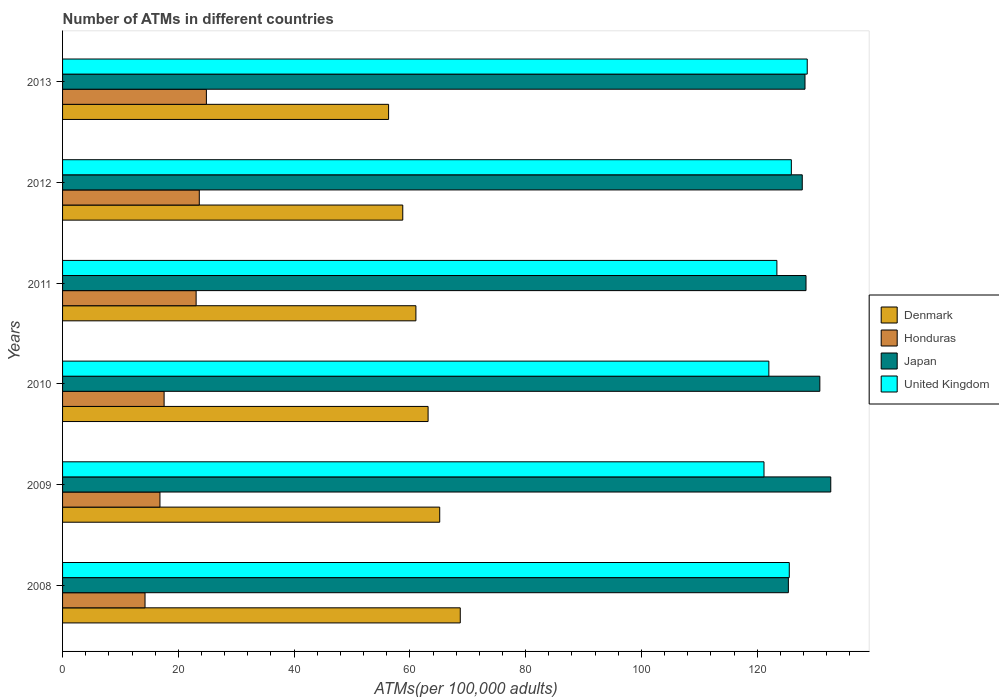How many groups of bars are there?
Offer a terse response. 6. Are the number of bars per tick equal to the number of legend labels?
Offer a terse response. Yes. Are the number of bars on each tick of the Y-axis equal?
Your answer should be compact. Yes. How many bars are there on the 2nd tick from the bottom?
Your answer should be very brief. 4. What is the number of ATMs in Honduras in 2009?
Give a very brief answer. 16.82. Across all years, what is the maximum number of ATMs in Honduras?
Your answer should be very brief. 24.85. Across all years, what is the minimum number of ATMs in Honduras?
Your response must be concise. 14.25. What is the total number of ATMs in United Kingdom in the graph?
Provide a succinct answer. 746.69. What is the difference between the number of ATMs in United Kingdom in 2009 and that in 2010?
Your answer should be compact. -0.84. What is the difference between the number of ATMs in Japan in 2010 and the number of ATMs in United Kingdom in 2011?
Offer a very short reply. 7.42. What is the average number of ATMs in Honduras per year?
Offer a very short reply. 20.03. In the year 2010, what is the difference between the number of ATMs in United Kingdom and number of ATMs in Denmark?
Ensure brevity in your answer.  58.87. In how many years, is the number of ATMs in Japan greater than 20 ?
Your answer should be compact. 6. What is the ratio of the number of ATMs in Honduras in 2012 to that in 2013?
Your answer should be compact. 0.95. What is the difference between the highest and the second highest number of ATMs in Japan?
Ensure brevity in your answer.  1.89. What is the difference between the highest and the lowest number of ATMs in Denmark?
Make the answer very short. 12.38. Is it the case that in every year, the sum of the number of ATMs in Honduras and number of ATMs in Japan is greater than the sum of number of ATMs in United Kingdom and number of ATMs in Denmark?
Keep it short and to the point. Yes. What does the 1st bar from the top in 2008 represents?
Offer a very short reply. United Kingdom. Is it the case that in every year, the sum of the number of ATMs in Japan and number of ATMs in United Kingdom is greater than the number of ATMs in Denmark?
Keep it short and to the point. Yes. Are all the bars in the graph horizontal?
Offer a very short reply. Yes. Are the values on the major ticks of X-axis written in scientific E-notation?
Your answer should be compact. No. Does the graph contain any zero values?
Give a very brief answer. No. Where does the legend appear in the graph?
Provide a short and direct response. Center right. How are the legend labels stacked?
Your answer should be compact. Vertical. What is the title of the graph?
Offer a very short reply. Number of ATMs in different countries. Does "Mongolia" appear as one of the legend labels in the graph?
Give a very brief answer. No. What is the label or title of the X-axis?
Provide a succinct answer. ATMs(per 100,0 adults). What is the label or title of the Y-axis?
Make the answer very short. Years. What is the ATMs(per 100,000 adults) of Denmark in 2008?
Ensure brevity in your answer.  68.71. What is the ATMs(per 100,000 adults) in Honduras in 2008?
Provide a succinct answer. 14.25. What is the ATMs(per 100,000 adults) of Japan in 2008?
Your answer should be very brief. 125.39. What is the ATMs(per 100,000 adults) in United Kingdom in 2008?
Keep it short and to the point. 125.55. What is the ATMs(per 100,000 adults) of Denmark in 2009?
Offer a terse response. 65.16. What is the ATMs(per 100,000 adults) of Honduras in 2009?
Make the answer very short. 16.82. What is the ATMs(per 100,000 adults) in Japan in 2009?
Provide a short and direct response. 132.71. What is the ATMs(per 100,000 adults) in United Kingdom in 2009?
Your answer should be compact. 121.18. What is the ATMs(per 100,000 adults) of Denmark in 2010?
Your answer should be very brief. 63.15. What is the ATMs(per 100,000 adults) of Honduras in 2010?
Your answer should be very brief. 17.54. What is the ATMs(per 100,000 adults) of Japan in 2010?
Keep it short and to the point. 130.82. What is the ATMs(per 100,000 adults) in United Kingdom in 2010?
Make the answer very short. 122.02. What is the ATMs(per 100,000 adults) in Denmark in 2011?
Keep it short and to the point. 61.04. What is the ATMs(per 100,000 adults) in Honduras in 2011?
Offer a very short reply. 23.07. What is the ATMs(per 100,000 adults) in Japan in 2011?
Make the answer very short. 128.44. What is the ATMs(per 100,000 adults) in United Kingdom in 2011?
Give a very brief answer. 123.4. What is the ATMs(per 100,000 adults) of Denmark in 2012?
Provide a short and direct response. 58.77. What is the ATMs(per 100,000 adults) of Honduras in 2012?
Give a very brief answer. 23.62. What is the ATMs(per 100,000 adults) in Japan in 2012?
Keep it short and to the point. 127.79. What is the ATMs(per 100,000 adults) of United Kingdom in 2012?
Offer a very short reply. 125.9. What is the ATMs(per 100,000 adults) of Denmark in 2013?
Your answer should be compact. 56.32. What is the ATMs(per 100,000 adults) in Honduras in 2013?
Make the answer very short. 24.85. What is the ATMs(per 100,000 adults) of Japan in 2013?
Make the answer very short. 128.26. What is the ATMs(per 100,000 adults) of United Kingdom in 2013?
Your answer should be compact. 128.65. Across all years, what is the maximum ATMs(per 100,000 adults) of Denmark?
Offer a terse response. 68.71. Across all years, what is the maximum ATMs(per 100,000 adults) in Honduras?
Your answer should be compact. 24.85. Across all years, what is the maximum ATMs(per 100,000 adults) of Japan?
Your answer should be compact. 132.71. Across all years, what is the maximum ATMs(per 100,000 adults) in United Kingdom?
Your answer should be compact. 128.65. Across all years, what is the minimum ATMs(per 100,000 adults) of Denmark?
Give a very brief answer. 56.32. Across all years, what is the minimum ATMs(per 100,000 adults) in Honduras?
Give a very brief answer. 14.25. Across all years, what is the minimum ATMs(per 100,000 adults) in Japan?
Keep it short and to the point. 125.39. Across all years, what is the minimum ATMs(per 100,000 adults) of United Kingdom?
Ensure brevity in your answer.  121.18. What is the total ATMs(per 100,000 adults) in Denmark in the graph?
Offer a very short reply. 373.15. What is the total ATMs(per 100,000 adults) in Honduras in the graph?
Make the answer very short. 120.15. What is the total ATMs(per 100,000 adults) of Japan in the graph?
Your answer should be very brief. 773.41. What is the total ATMs(per 100,000 adults) of United Kingdom in the graph?
Provide a short and direct response. 746.69. What is the difference between the ATMs(per 100,000 adults) of Denmark in 2008 and that in 2009?
Your answer should be compact. 3.55. What is the difference between the ATMs(per 100,000 adults) of Honduras in 2008 and that in 2009?
Provide a succinct answer. -2.58. What is the difference between the ATMs(per 100,000 adults) in Japan in 2008 and that in 2009?
Offer a terse response. -7.32. What is the difference between the ATMs(per 100,000 adults) in United Kingdom in 2008 and that in 2009?
Offer a very short reply. 4.37. What is the difference between the ATMs(per 100,000 adults) of Denmark in 2008 and that in 2010?
Your answer should be compact. 5.56. What is the difference between the ATMs(per 100,000 adults) of Honduras in 2008 and that in 2010?
Ensure brevity in your answer.  -3.29. What is the difference between the ATMs(per 100,000 adults) of Japan in 2008 and that in 2010?
Provide a short and direct response. -5.44. What is the difference between the ATMs(per 100,000 adults) in United Kingdom in 2008 and that in 2010?
Make the answer very short. 3.53. What is the difference between the ATMs(per 100,000 adults) in Denmark in 2008 and that in 2011?
Your answer should be compact. 7.66. What is the difference between the ATMs(per 100,000 adults) of Honduras in 2008 and that in 2011?
Offer a very short reply. -8.83. What is the difference between the ATMs(per 100,000 adults) in Japan in 2008 and that in 2011?
Your answer should be compact. -3.05. What is the difference between the ATMs(per 100,000 adults) in United Kingdom in 2008 and that in 2011?
Keep it short and to the point. 2.14. What is the difference between the ATMs(per 100,000 adults) in Denmark in 2008 and that in 2012?
Provide a succinct answer. 9.93. What is the difference between the ATMs(per 100,000 adults) in Honduras in 2008 and that in 2012?
Ensure brevity in your answer.  -9.37. What is the difference between the ATMs(per 100,000 adults) of Japan in 2008 and that in 2012?
Give a very brief answer. -2.4. What is the difference between the ATMs(per 100,000 adults) of United Kingdom in 2008 and that in 2012?
Offer a terse response. -0.36. What is the difference between the ATMs(per 100,000 adults) in Denmark in 2008 and that in 2013?
Keep it short and to the point. 12.38. What is the difference between the ATMs(per 100,000 adults) in Honduras in 2008 and that in 2013?
Ensure brevity in your answer.  -10.6. What is the difference between the ATMs(per 100,000 adults) of Japan in 2008 and that in 2013?
Offer a terse response. -2.87. What is the difference between the ATMs(per 100,000 adults) in United Kingdom in 2008 and that in 2013?
Keep it short and to the point. -3.1. What is the difference between the ATMs(per 100,000 adults) of Denmark in 2009 and that in 2010?
Your answer should be compact. 2.01. What is the difference between the ATMs(per 100,000 adults) of Honduras in 2009 and that in 2010?
Offer a terse response. -0.72. What is the difference between the ATMs(per 100,000 adults) of Japan in 2009 and that in 2010?
Provide a succinct answer. 1.89. What is the difference between the ATMs(per 100,000 adults) of United Kingdom in 2009 and that in 2010?
Keep it short and to the point. -0.84. What is the difference between the ATMs(per 100,000 adults) in Denmark in 2009 and that in 2011?
Provide a short and direct response. 4.11. What is the difference between the ATMs(per 100,000 adults) in Honduras in 2009 and that in 2011?
Offer a very short reply. -6.25. What is the difference between the ATMs(per 100,000 adults) in Japan in 2009 and that in 2011?
Ensure brevity in your answer.  4.28. What is the difference between the ATMs(per 100,000 adults) in United Kingdom in 2009 and that in 2011?
Your response must be concise. -2.23. What is the difference between the ATMs(per 100,000 adults) of Denmark in 2009 and that in 2012?
Give a very brief answer. 6.38. What is the difference between the ATMs(per 100,000 adults) in Honduras in 2009 and that in 2012?
Ensure brevity in your answer.  -6.8. What is the difference between the ATMs(per 100,000 adults) in Japan in 2009 and that in 2012?
Provide a short and direct response. 4.92. What is the difference between the ATMs(per 100,000 adults) of United Kingdom in 2009 and that in 2012?
Your response must be concise. -4.72. What is the difference between the ATMs(per 100,000 adults) in Denmark in 2009 and that in 2013?
Ensure brevity in your answer.  8.83. What is the difference between the ATMs(per 100,000 adults) in Honduras in 2009 and that in 2013?
Your response must be concise. -8.02. What is the difference between the ATMs(per 100,000 adults) in Japan in 2009 and that in 2013?
Keep it short and to the point. 4.45. What is the difference between the ATMs(per 100,000 adults) of United Kingdom in 2009 and that in 2013?
Your response must be concise. -7.47. What is the difference between the ATMs(per 100,000 adults) of Denmark in 2010 and that in 2011?
Your answer should be very brief. 2.11. What is the difference between the ATMs(per 100,000 adults) in Honduras in 2010 and that in 2011?
Your answer should be compact. -5.53. What is the difference between the ATMs(per 100,000 adults) in Japan in 2010 and that in 2011?
Your response must be concise. 2.39. What is the difference between the ATMs(per 100,000 adults) of United Kingdom in 2010 and that in 2011?
Your response must be concise. -1.39. What is the difference between the ATMs(per 100,000 adults) in Denmark in 2010 and that in 2012?
Provide a short and direct response. 4.38. What is the difference between the ATMs(per 100,000 adults) of Honduras in 2010 and that in 2012?
Keep it short and to the point. -6.08. What is the difference between the ATMs(per 100,000 adults) in Japan in 2010 and that in 2012?
Keep it short and to the point. 3.04. What is the difference between the ATMs(per 100,000 adults) of United Kingdom in 2010 and that in 2012?
Provide a short and direct response. -3.89. What is the difference between the ATMs(per 100,000 adults) of Denmark in 2010 and that in 2013?
Your answer should be very brief. 6.83. What is the difference between the ATMs(per 100,000 adults) of Honduras in 2010 and that in 2013?
Provide a succinct answer. -7.3. What is the difference between the ATMs(per 100,000 adults) of Japan in 2010 and that in 2013?
Ensure brevity in your answer.  2.56. What is the difference between the ATMs(per 100,000 adults) in United Kingdom in 2010 and that in 2013?
Keep it short and to the point. -6.63. What is the difference between the ATMs(per 100,000 adults) in Denmark in 2011 and that in 2012?
Offer a very short reply. 2.27. What is the difference between the ATMs(per 100,000 adults) of Honduras in 2011 and that in 2012?
Give a very brief answer. -0.55. What is the difference between the ATMs(per 100,000 adults) in Japan in 2011 and that in 2012?
Provide a short and direct response. 0.65. What is the difference between the ATMs(per 100,000 adults) in United Kingdom in 2011 and that in 2012?
Your answer should be very brief. -2.5. What is the difference between the ATMs(per 100,000 adults) of Denmark in 2011 and that in 2013?
Provide a short and direct response. 4.72. What is the difference between the ATMs(per 100,000 adults) of Honduras in 2011 and that in 2013?
Your response must be concise. -1.77. What is the difference between the ATMs(per 100,000 adults) in Japan in 2011 and that in 2013?
Offer a terse response. 0.17. What is the difference between the ATMs(per 100,000 adults) of United Kingdom in 2011 and that in 2013?
Provide a succinct answer. -5.24. What is the difference between the ATMs(per 100,000 adults) in Denmark in 2012 and that in 2013?
Give a very brief answer. 2.45. What is the difference between the ATMs(per 100,000 adults) in Honduras in 2012 and that in 2013?
Make the answer very short. -1.22. What is the difference between the ATMs(per 100,000 adults) of Japan in 2012 and that in 2013?
Your response must be concise. -0.47. What is the difference between the ATMs(per 100,000 adults) in United Kingdom in 2012 and that in 2013?
Ensure brevity in your answer.  -2.74. What is the difference between the ATMs(per 100,000 adults) of Denmark in 2008 and the ATMs(per 100,000 adults) of Honduras in 2009?
Offer a terse response. 51.88. What is the difference between the ATMs(per 100,000 adults) of Denmark in 2008 and the ATMs(per 100,000 adults) of Japan in 2009?
Offer a terse response. -64.01. What is the difference between the ATMs(per 100,000 adults) in Denmark in 2008 and the ATMs(per 100,000 adults) in United Kingdom in 2009?
Offer a terse response. -52.47. What is the difference between the ATMs(per 100,000 adults) in Honduras in 2008 and the ATMs(per 100,000 adults) in Japan in 2009?
Provide a succinct answer. -118.47. What is the difference between the ATMs(per 100,000 adults) in Honduras in 2008 and the ATMs(per 100,000 adults) in United Kingdom in 2009?
Offer a very short reply. -106.93. What is the difference between the ATMs(per 100,000 adults) in Japan in 2008 and the ATMs(per 100,000 adults) in United Kingdom in 2009?
Keep it short and to the point. 4.21. What is the difference between the ATMs(per 100,000 adults) in Denmark in 2008 and the ATMs(per 100,000 adults) in Honduras in 2010?
Your answer should be very brief. 51.16. What is the difference between the ATMs(per 100,000 adults) in Denmark in 2008 and the ATMs(per 100,000 adults) in Japan in 2010?
Offer a terse response. -62.12. What is the difference between the ATMs(per 100,000 adults) in Denmark in 2008 and the ATMs(per 100,000 adults) in United Kingdom in 2010?
Offer a terse response. -53.31. What is the difference between the ATMs(per 100,000 adults) in Honduras in 2008 and the ATMs(per 100,000 adults) in Japan in 2010?
Make the answer very short. -116.58. What is the difference between the ATMs(per 100,000 adults) in Honduras in 2008 and the ATMs(per 100,000 adults) in United Kingdom in 2010?
Your response must be concise. -107.77. What is the difference between the ATMs(per 100,000 adults) of Japan in 2008 and the ATMs(per 100,000 adults) of United Kingdom in 2010?
Provide a succinct answer. 3.37. What is the difference between the ATMs(per 100,000 adults) of Denmark in 2008 and the ATMs(per 100,000 adults) of Honduras in 2011?
Keep it short and to the point. 45.63. What is the difference between the ATMs(per 100,000 adults) in Denmark in 2008 and the ATMs(per 100,000 adults) in Japan in 2011?
Provide a short and direct response. -59.73. What is the difference between the ATMs(per 100,000 adults) in Denmark in 2008 and the ATMs(per 100,000 adults) in United Kingdom in 2011?
Keep it short and to the point. -54.7. What is the difference between the ATMs(per 100,000 adults) in Honduras in 2008 and the ATMs(per 100,000 adults) in Japan in 2011?
Offer a very short reply. -114.19. What is the difference between the ATMs(per 100,000 adults) of Honduras in 2008 and the ATMs(per 100,000 adults) of United Kingdom in 2011?
Offer a terse response. -109.16. What is the difference between the ATMs(per 100,000 adults) in Japan in 2008 and the ATMs(per 100,000 adults) in United Kingdom in 2011?
Your answer should be very brief. 1.98. What is the difference between the ATMs(per 100,000 adults) in Denmark in 2008 and the ATMs(per 100,000 adults) in Honduras in 2012?
Your response must be concise. 45.08. What is the difference between the ATMs(per 100,000 adults) of Denmark in 2008 and the ATMs(per 100,000 adults) of Japan in 2012?
Offer a very short reply. -59.08. What is the difference between the ATMs(per 100,000 adults) of Denmark in 2008 and the ATMs(per 100,000 adults) of United Kingdom in 2012?
Provide a short and direct response. -57.2. What is the difference between the ATMs(per 100,000 adults) of Honduras in 2008 and the ATMs(per 100,000 adults) of Japan in 2012?
Ensure brevity in your answer.  -113.54. What is the difference between the ATMs(per 100,000 adults) in Honduras in 2008 and the ATMs(per 100,000 adults) in United Kingdom in 2012?
Offer a terse response. -111.65. What is the difference between the ATMs(per 100,000 adults) in Japan in 2008 and the ATMs(per 100,000 adults) in United Kingdom in 2012?
Keep it short and to the point. -0.51. What is the difference between the ATMs(per 100,000 adults) in Denmark in 2008 and the ATMs(per 100,000 adults) in Honduras in 2013?
Your response must be concise. 43.86. What is the difference between the ATMs(per 100,000 adults) of Denmark in 2008 and the ATMs(per 100,000 adults) of Japan in 2013?
Provide a succinct answer. -59.56. What is the difference between the ATMs(per 100,000 adults) of Denmark in 2008 and the ATMs(per 100,000 adults) of United Kingdom in 2013?
Your answer should be compact. -59.94. What is the difference between the ATMs(per 100,000 adults) of Honduras in 2008 and the ATMs(per 100,000 adults) of Japan in 2013?
Make the answer very short. -114.01. What is the difference between the ATMs(per 100,000 adults) of Honduras in 2008 and the ATMs(per 100,000 adults) of United Kingdom in 2013?
Offer a terse response. -114.4. What is the difference between the ATMs(per 100,000 adults) in Japan in 2008 and the ATMs(per 100,000 adults) in United Kingdom in 2013?
Provide a succinct answer. -3.26. What is the difference between the ATMs(per 100,000 adults) in Denmark in 2009 and the ATMs(per 100,000 adults) in Honduras in 2010?
Offer a very short reply. 47.61. What is the difference between the ATMs(per 100,000 adults) of Denmark in 2009 and the ATMs(per 100,000 adults) of Japan in 2010?
Your response must be concise. -65.67. What is the difference between the ATMs(per 100,000 adults) of Denmark in 2009 and the ATMs(per 100,000 adults) of United Kingdom in 2010?
Provide a short and direct response. -56.86. What is the difference between the ATMs(per 100,000 adults) in Honduras in 2009 and the ATMs(per 100,000 adults) in Japan in 2010?
Ensure brevity in your answer.  -114. What is the difference between the ATMs(per 100,000 adults) in Honduras in 2009 and the ATMs(per 100,000 adults) in United Kingdom in 2010?
Provide a succinct answer. -105.19. What is the difference between the ATMs(per 100,000 adults) of Japan in 2009 and the ATMs(per 100,000 adults) of United Kingdom in 2010?
Your answer should be very brief. 10.7. What is the difference between the ATMs(per 100,000 adults) in Denmark in 2009 and the ATMs(per 100,000 adults) in Honduras in 2011?
Give a very brief answer. 42.08. What is the difference between the ATMs(per 100,000 adults) in Denmark in 2009 and the ATMs(per 100,000 adults) in Japan in 2011?
Your answer should be very brief. -63.28. What is the difference between the ATMs(per 100,000 adults) in Denmark in 2009 and the ATMs(per 100,000 adults) in United Kingdom in 2011?
Offer a terse response. -58.25. What is the difference between the ATMs(per 100,000 adults) of Honduras in 2009 and the ATMs(per 100,000 adults) of Japan in 2011?
Offer a terse response. -111.61. What is the difference between the ATMs(per 100,000 adults) in Honduras in 2009 and the ATMs(per 100,000 adults) in United Kingdom in 2011?
Ensure brevity in your answer.  -106.58. What is the difference between the ATMs(per 100,000 adults) of Japan in 2009 and the ATMs(per 100,000 adults) of United Kingdom in 2011?
Make the answer very short. 9.31. What is the difference between the ATMs(per 100,000 adults) in Denmark in 2009 and the ATMs(per 100,000 adults) in Honduras in 2012?
Your response must be concise. 41.54. What is the difference between the ATMs(per 100,000 adults) in Denmark in 2009 and the ATMs(per 100,000 adults) in Japan in 2012?
Make the answer very short. -62.63. What is the difference between the ATMs(per 100,000 adults) in Denmark in 2009 and the ATMs(per 100,000 adults) in United Kingdom in 2012?
Give a very brief answer. -60.75. What is the difference between the ATMs(per 100,000 adults) in Honduras in 2009 and the ATMs(per 100,000 adults) in Japan in 2012?
Offer a very short reply. -110.96. What is the difference between the ATMs(per 100,000 adults) of Honduras in 2009 and the ATMs(per 100,000 adults) of United Kingdom in 2012?
Provide a short and direct response. -109.08. What is the difference between the ATMs(per 100,000 adults) in Japan in 2009 and the ATMs(per 100,000 adults) in United Kingdom in 2012?
Your response must be concise. 6.81. What is the difference between the ATMs(per 100,000 adults) in Denmark in 2009 and the ATMs(per 100,000 adults) in Honduras in 2013?
Keep it short and to the point. 40.31. What is the difference between the ATMs(per 100,000 adults) of Denmark in 2009 and the ATMs(per 100,000 adults) of Japan in 2013?
Ensure brevity in your answer.  -63.1. What is the difference between the ATMs(per 100,000 adults) of Denmark in 2009 and the ATMs(per 100,000 adults) of United Kingdom in 2013?
Your answer should be very brief. -63.49. What is the difference between the ATMs(per 100,000 adults) of Honduras in 2009 and the ATMs(per 100,000 adults) of Japan in 2013?
Your answer should be very brief. -111.44. What is the difference between the ATMs(per 100,000 adults) in Honduras in 2009 and the ATMs(per 100,000 adults) in United Kingdom in 2013?
Your response must be concise. -111.82. What is the difference between the ATMs(per 100,000 adults) in Japan in 2009 and the ATMs(per 100,000 adults) in United Kingdom in 2013?
Your response must be concise. 4.07. What is the difference between the ATMs(per 100,000 adults) in Denmark in 2010 and the ATMs(per 100,000 adults) in Honduras in 2011?
Offer a very short reply. 40.08. What is the difference between the ATMs(per 100,000 adults) in Denmark in 2010 and the ATMs(per 100,000 adults) in Japan in 2011?
Offer a very short reply. -65.29. What is the difference between the ATMs(per 100,000 adults) in Denmark in 2010 and the ATMs(per 100,000 adults) in United Kingdom in 2011?
Offer a terse response. -60.26. What is the difference between the ATMs(per 100,000 adults) of Honduras in 2010 and the ATMs(per 100,000 adults) of Japan in 2011?
Make the answer very short. -110.89. What is the difference between the ATMs(per 100,000 adults) in Honduras in 2010 and the ATMs(per 100,000 adults) in United Kingdom in 2011?
Keep it short and to the point. -105.86. What is the difference between the ATMs(per 100,000 adults) in Japan in 2010 and the ATMs(per 100,000 adults) in United Kingdom in 2011?
Ensure brevity in your answer.  7.42. What is the difference between the ATMs(per 100,000 adults) of Denmark in 2010 and the ATMs(per 100,000 adults) of Honduras in 2012?
Offer a terse response. 39.53. What is the difference between the ATMs(per 100,000 adults) in Denmark in 2010 and the ATMs(per 100,000 adults) in Japan in 2012?
Give a very brief answer. -64.64. What is the difference between the ATMs(per 100,000 adults) of Denmark in 2010 and the ATMs(per 100,000 adults) of United Kingdom in 2012?
Your answer should be very brief. -62.75. What is the difference between the ATMs(per 100,000 adults) in Honduras in 2010 and the ATMs(per 100,000 adults) in Japan in 2012?
Keep it short and to the point. -110.25. What is the difference between the ATMs(per 100,000 adults) of Honduras in 2010 and the ATMs(per 100,000 adults) of United Kingdom in 2012?
Your response must be concise. -108.36. What is the difference between the ATMs(per 100,000 adults) in Japan in 2010 and the ATMs(per 100,000 adults) in United Kingdom in 2012?
Your answer should be compact. 4.92. What is the difference between the ATMs(per 100,000 adults) in Denmark in 2010 and the ATMs(per 100,000 adults) in Honduras in 2013?
Provide a short and direct response. 38.3. What is the difference between the ATMs(per 100,000 adults) in Denmark in 2010 and the ATMs(per 100,000 adults) in Japan in 2013?
Provide a short and direct response. -65.11. What is the difference between the ATMs(per 100,000 adults) of Denmark in 2010 and the ATMs(per 100,000 adults) of United Kingdom in 2013?
Offer a terse response. -65.5. What is the difference between the ATMs(per 100,000 adults) in Honduras in 2010 and the ATMs(per 100,000 adults) in Japan in 2013?
Offer a very short reply. -110.72. What is the difference between the ATMs(per 100,000 adults) of Honduras in 2010 and the ATMs(per 100,000 adults) of United Kingdom in 2013?
Offer a very short reply. -111.1. What is the difference between the ATMs(per 100,000 adults) in Japan in 2010 and the ATMs(per 100,000 adults) in United Kingdom in 2013?
Offer a terse response. 2.18. What is the difference between the ATMs(per 100,000 adults) in Denmark in 2011 and the ATMs(per 100,000 adults) in Honduras in 2012?
Offer a terse response. 37.42. What is the difference between the ATMs(per 100,000 adults) of Denmark in 2011 and the ATMs(per 100,000 adults) of Japan in 2012?
Your answer should be compact. -66.75. What is the difference between the ATMs(per 100,000 adults) of Denmark in 2011 and the ATMs(per 100,000 adults) of United Kingdom in 2012?
Offer a terse response. -64.86. What is the difference between the ATMs(per 100,000 adults) in Honduras in 2011 and the ATMs(per 100,000 adults) in Japan in 2012?
Make the answer very short. -104.72. What is the difference between the ATMs(per 100,000 adults) of Honduras in 2011 and the ATMs(per 100,000 adults) of United Kingdom in 2012?
Offer a terse response. -102.83. What is the difference between the ATMs(per 100,000 adults) in Japan in 2011 and the ATMs(per 100,000 adults) in United Kingdom in 2012?
Offer a very short reply. 2.53. What is the difference between the ATMs(per 100,000 adults) in Denmark in 2011 and the ATMs(per 100,000 adults) in Honduras in 2013?
Provide a short and direct response. 36.2. What is the difference between the ATMs(per 100,000 adults) in Denmark in 2011 and the ATMs(per 100,000 adults) in Japan in 2013?
Ensure brevity in your answer.  -67.22. What is the difference between the ATMs(per 100,000 adults) in Denmark in 2011 and the ATMs(per 100,000 adults) in United Kingdom in 2013?
Keep it short and to the point. -67.6. What is the difference between the ATMs(per 100,000 adults) in Honduras in 2011 and the ATMs(per 100,000 adults) in Japan in 2013?
Your response must be concise. -105.19. What is the difference between the ATMs(per 100,000 adults) in Honduras in 2011 and the ATMs(per 100,000 adults) in United Kingdom in 2013?
Ensure brevity in your answer.  -105.57. What is the difference between the ATMs(per 100,000 adults) of Japan in 2011 and the ATMs(per 100,000 adults) of United Kingdom in 2013?
Provide a succinct answer. -0.21. What is the difference between the ATMs(per 100,000 adults) of Denmark in 2012 and the ATMs(per 100,000 adults) of Honduras in 2013?
Ensure brevity in your answer.  33.93. What is the difference between the ATMs(per 100,000 adults) of Denmark in 2012 and the ATMs(per 100,000 adults) of Japan in 2013?
Give a very brief answer. -69.49. What is the difference between the ATMs(per 100,000 adults) of Denmark in 2012 and the ATMs(per 100,000 adults) of United Kingdom in 2013?
Provide a short and direct response. -69.87. What is the difference between the ATMs(per 100,000 adults) of Honduras in 2012 and the ATMs(per 100,000 adults) of Japan in 2013?
Give a very brief answer. -104.64. What is the difference between the ATMs(per 100,000 adults) of Honduras in 2012 and the ATMs(per 100,000 adults) of United Kingdom in 2013?
Your response must be concise. -105.03. What is the difference between the ATMs(per 100,000 adults) in Japan in 2012 and the ATMs(per 100,000 adults) in United Kingdom in 2013?
Provide a short and direct response. -0.86. What is the average ATMs(per 100,000 adults) in Denmark per year?
Provide a succinct answer. 62.19. What is the average ATMs(per 100,000 adults) of Honduras per year?
Your response must be concise. 20.03. What is the average ATMs(per 100,000 adults) of Japan per year?
Your response must be concise. 128.9. What is the average ATMs(per 100,000 adults) in United Kingdom per year?
Offer a very short reply. 124.45. In the year 2008, what is the difference between the ATMs(per 100,000 adults) of Denmark and ATMs(per 100,000 adults) of Honduras?
Your answer should be compact. 54.46. In the year 2008, what is the difference between the ATMs(per 100,000 adults) of Denmark and ATMs(per 100,000 adults) of Japan?
Provide a short and direct response. -56.68. In the year 2008, what is the difference between the ATMs(per 100,000 adults) in Denmark and ATMs(per 100,000 adults) in United Kingdom?
Offer a terse response. -56.84. In the year 2008, what is the difference between the ATMs(per 100,000 adults) of Honduras and ATMs(per 100,000 adults) of Japan?
Your response must be concise. -111.14. In the year 2008, what is the difference between the ATMs(per 100,000 adults) of Honduras and ATMs(per 100,000 adults) of United Kingdom?
Offer a terse response. -111.3. In the year 2008, what is the difference between the ATMs(per 100,000 adults) of Japan and ATMs(per 100,000 adults) of United Kingdom?
Your answer should be compact. -0.16. In the year 2009, what is the difference between the ATMs(per 100,000 adults) in Denmark and ATMs(per 100,000 adults) in Honduras?
Provide a short and direct response. 48.33. In the year 2009, what is the difference between the ATMs(per 100,000 adults) of Denmark and ATMs(per 100,000 adults) of Japan?
Offer a terse response. -67.56. In the year 2009, what is the difference between the ATMs(per 100,000 adults) in Denmark and ATMs(per 100,000 adults) in United Kingdom?
Offer a terse response. -56.02. In the year 2009, what is the difference between the ATMs(per 100,000 adults) of Honduras and ATMs(per 100,000 adults) of Japan?
Your answer should be very brief. -115.89. In the year 2009, what is the difference between the ATMs(per 100,000 adults) in Honduras and ATMs(per 100,000 adults) in United Kingdom?
Offer a very short reply. -104.35. In the year 2009, what is the difference between the ATMs(per 100,000 adults) of Japan and ATMs(per 100,000 adults) of United Kingdom?
Your answer should be very brief. 11.54. In the year 2010, what is the difference between the ATMs(per 100,000 adults) of Denmark and ATMs(per 100,000 adults) of Honduras?
Offer a terse response. 45.61. In the year 2010, what is the difference between the ATMs(per 100,000 adults) in Denmark and ATMs(per 100,000 adults) in Japan?
Your answer should be compact. -67.68. In the year 2010, what is the difference between the ATMs(per 100,000 adults) in Denmark and ATMs(per 100,000 adults) in United Kingdom?
Ensure brevity in your answer.  -58.87. In the year 2010, what is the difference between the ATMs(per 100,000 adults) in Honduras and ATMs(per 100,000 adults) in Japan?
Your response must be concise. -113.28. In the year 2010, what is the difference between the ATMs(per 100,000 adults) in Honduras and ATMs(per 100,000 adults) in United Kingdom?
Offer a terse response. -104.47. In the year 2010, what is the difference between the ATMs(per 100,000 adults) in Japan and ATMs(per 100,000 adults) in United Kingdom?
Provide a short and direct response. 8.81. In the year 2011, what is the difference between the ATMs(per 100,000 adults) in Denmark and ATMs(per 100,000 adults) in Honduras?
Ensure brevity in your answer.  37.97. In the year 2011, what is the difference between the ATMs(per 100,000 adults) of Denmark and ATMs(per 100,000 adults) of Japan?
Offer a terse response. -67.39. In the year 2011, what is the difference between the ATMs(per 100,000 adults) in Denmark and ATMs(per 100,000 adults) in United Kingdom?
Make the answer very short. -62.36. In the year 2011, what is the difference between the ATMs(per 100,000 adults) in Honduras and ATMs(per 100,000 adults) in Japan?
Give a very brief answer. -105.36. In the year 2011, what is the difference between the ATMs(per 100,000 adults) in Honduras and ATMs(per 100,000 adults) in United Kingdom?
Provide a succinct answer. -100.33. In the year 2011, what is the difference between the ATMs(per 100,000 adults) in Japan and ATMs(per 100,000 adults) in United Kingdom?
Make the answer very short. 5.03. In the year 2012, what is the difference between the ATMs(per 100,000 adults) of Denmark and ATMs(per 100,000 adults) of Honduras?
Keep it short and to the point. 35.15. In the year 2012, what is the difference between the ATMs(per 100,000 adults) in Denmark and ATMs(per 100,000 adults) in Japan?
Keep it short and to the point. -69.02. In the year 2012, what is the difference between the ATMs(per 100,000 adults) of Denmark and ATMs(per 100,000 adults) of United Kingdom?
Your answer should be compact. -67.13. In the year 2012, what is the difference between the ATMs(per 100,000 adults) of Honduras and ATMs(per 100,000 adults) of Japan?
Provide a succinct answer. -104.17. In the year 2012, what is the difference between the ATMs(per 100,000 adults) of Honduras and ATMs(per 100,000 adults) of United Kingdom?
Your answer should be very brief. -102.28. In the year 2012, what is the difference between the ATMs(per 100,000 adults) of Japan and ATMs(per 100,000 adults) of United Kingdom?
Provide a short and direct response. 1.89. In the year 2013, what is the difference between the ATMs(per 100,000 adults) of Denmark and ATMs(per 100,000 adults) of Honduras?
Provide a succinct answer. 31.48. In the year 2013, what is the difference between the ATMs(per 100,000 adults) of Denmark and ATMs(per 100,000 adults) of Japan?
Keep it short and to the point. -71.94. In the year 2013, what is the difference between the ATMs(per 100,000 adults) of Denmark and ATMs(per 100,000 adults) of United Kingdom?
Ensure brevity in your answer.  -72.32. In the year 2013, what is the difference between the ATMs(per 100,000 adults) in Honduras and ATMs(per 100,000 adults) in Japan?
Make the answer very short. -103.42. In the year 2013, what is the difference between the ATMs(per 100,000 adults) in Honduras and ATMs(per 100,000 adults) in United Kingdom?
Ensure brevity in your answer.  -103.8. In the year 2013, what is the difference between the ATMs(per 100,000 adults) in Japan and ATMs(per 100,000 adults) in United Kingdom?
Give a very brief answer. -0.39. What is the ratio of the ATMs(per 100,000 adults) in Denmark in 2008 to that in 2009?
Ensure brevity in your answer.  1.05. What is the ratio of the ATMs(per 100,000 adults) in Honduras in 2008 to that in 2009?
Give a very brief answer. 0.85. What is the ratio of the ATMs(per 100,000 adults) of Japan in 2008 to that in 2009?
Your answer should be compact. 0.94. What is the ratio of the ATMs(per 100,000 adults) of United Kingdom in 2008 to that in 2009?
Ensure brevity in your answer.  1.04. What is the ratio of the ATMs(per 100,000 adults) of Denmark in 2008 to that in 2010?
Provide a succinct answer. 1.09. What is the ratio of the ATMs(per 100,000 adults) in Honduras in 2008 to that in 2010?
Provide a succinct answer. 0.81. What is the ratio of the ATMs(per 100,000 adults) of Japan in 2008 to that in 2010?
Give a very brief answer. 0.96. What is the ratio of the ATMs(per 100,000 adults) of United Kingdom in 2008 to that in 2010?
Ensure brevity in your answer.  1.03. What is the ratio of the ATMs(per 100,000 adults) in Denmark in 2008 to that in 2011?
Provide a short and direct response. 1.13. What is the ratio of the ATMs(per 100,000 adults) in Honduras in 2008 to that in 2011?
Make the answer very short. 0.62. What is the ratio of the ATMs(per 100,000 adults) of Japan in 2008 to that in 2011?
Your answer should be very brief. 0.98. What is the ratio of the ATMs(per 100,000 adults) of United Kingdom in 2008 to that in 2011?
Give a very brief answer. 1.02. What is the ratio of the ATMs(per 100,000 adults) of Denmark in 2008 to that in 2012?
Your response must be concise. 1.17. What is the ratio of the ATMs(per 100,000 adults) of Honduras in 2008 to that in 2012?
Make the answer very short. 0.6. What is the ratio of the ATMs(per 100,000 adults) in Japan in 2008 to that in 2012?
Make the answer very short. 0.98. What is the ratio of the ATMs(per 100,000 adults) in Denmark in 2008 to that in 2013?
Offer a terse response. 1.22. What is the ratio of the ATMs(per 100,000 adults) in Honduras in 2008 to that in 2013?
Provide a short and direct response. 0.57. What is the ratio of the ATMs(per 100,000 adults) in Japan in 2008 to that in 2013?
Offer a terse response. 0.98. What is the ratio of the ATMs(per 100,000 adults) in United Kingdom in 2008 to that in 2013?
Your answer should be compact. 0.98. What is the ratio of the ATMs(per 100,000 adults) of Denmark in 2009 to that in 2010?
Offer a very short reply. 1.03. What is the ratio of the ATMs(per 100,000 adults) of Honduras in 2009 to that in 2010?
Offer a terse response. 0.96. What is the ratio of the ATMs(per 100,000 adults) in Japan in 2009 to that in 2010?
Your answer should be compact. 1.01. What is the ratio of the ATMs(per 100,000 adults) in Denmark in 2009 to that in 2011?
Your answer should be compact. 1.07. What is the ratio of the ATMs(per 100,000 adults) in Honduras in 2009 to that in 2011?
Keep it short and to the point. 0.73. What is the ratio of the ATMs(per 100,000 adults) in Japan in 2009 to that in 2011?
Offer a terse response. 1.03. What is the ratio of the ATMs(per 100,000 adults) in Denmark in 2009 to that in 2012?
Provide a short and direct response. 1.11. What is the ratio of the ATMs(per 100,000 adults) in Honduras in 2009 to that in 2012?
Provide a short and direct response. 0.71. What is the ratio of the ATMs(per 100,000 adults) of United Kingdom in 2009 to that in 2012?
Your answer should be very brief. 0.96. What is the ratio of the ATMs(per 100,000 adults) of Denmark in 2009 to that in 2013?
Make the answer very short. 1.16. What is the ratio of the ATMs(per 100,000 adults) of Honduras in 2009 to that in 2013?
Provide a succinct answer. 0.68. What is the ratio of the ATMs(per 100,000 adults) in Japan in 2009 to that in 2013?
Your response must be concise. 1.03. What is the ratio of the ATMs(per 100,000 adults) of United Kingdom in 2009 to that in 2013?
Provide a short and direct response. 0.94. What is the ratio of the ATMs(per 100,000 adults) of Denmark in 2010 to that in 2011?
Your response must be concise. 1.03. What is the ratio of the ATMs(per 100,000 adults) of Honduras in 2010 to that in 2011?
Provide a succinct answer. 0.76. What is the ratio of the ATMs(per 100,000 adults) in Japan in 2010 to that in 2011?
Keep it short and to the point. 1.02. What is the ratio of the ATMs(per 100,000 adults) of United Kingdom in 2010 to that in 2011?
Keep it short and to the point. 0.99. What is the ratio of the ATMs(per 100,000 adults) of Denmark in 2010 to that in 2012?
Keep it short and to the point. 1.07. What is the ratio of the ATMs(per 100,000 adults) of Honduras in 2010 to that in 2012?
Your answer should be very brief. 0.74. What is the ratio of the ATMs(per 100,000 adults) of Japan in 2010 to that in 2012?
Provide a succinct answer. 1.02. What is the ratio of the ATMs(per 100,000 adults) in United Kingdom in 2010 to that in 2012?
Provide a short and direct response. 0.97. What is the ratio of the ATMs(per 100,000 adults) of Denmark in 2010 to that in 2013?
Your answer should be compact. 1.12. What is the ratio of the ATMs(per 100,000 adults) of Honduras in 2010 to that in 2013?
Your answer should be compact. 0.71. What is the ratio of the ATMs(per 100,000 adults) in Japan in 2010 to that in 2013?
Your response must be concise. 1.02. What is the ratio of the ATMs(per 100,000 adults) of United Kingdom in 2010 to that in 2013?
Your response must be concise. 0.95. What is the ratio of the ATMs(per 100,000 adults) of Denmark in 2011 to that in 2012?
Make the answer very short. 1.04. What is the ratio of the ATMs(per 100,000 adults) of Honduras in 2011 to that in 2012?
Provide a succinct answer. 0.98. What is the ratio of the ATMs(per 100,000 adults) of United Kingdom in 2011 to that in 2012?
Your answer should be very brief. 0.98. What is the ratio of the ATMs(per 100,000 adults) in Denmark in 2011 to that in 2013?
Your response must be concise. 1.08. What is the ratio of the ATMs(per 100,000 adults) in Honduras in 2011 to that in 2013?
Keep it short and to the point. 0.93. What is the ratio of the ATMs(per 100,000 adults) of United Kingdom in 2011 to that in 2013?
Offer a very short reply. 0.96. What is the ratio of the ATMs(per 100,000 adults) of Denmark in 2012 to that in 2013?
Your answer should be very brief. 1.04. What is the ratio of the ATMs(per 100,000 adults) in Honduras in 2012 to that in 2013?
Your answer should be compact. 0.95. What is the ratio of the ATMs(per 100,000 adults) in United Kingdom in 2012 to that in 2013?
Give a very brief answer. 0.98. What is the difference between the highest and the second highest ATMs(per 100,000 adults) in Denmark?
Your answer should be very brief. 3.55. What is the difference between the highest and the second highest ATMs(per 100,000 adults) in Honduras?
Your answer should be compact. 1.22. What is the difference between the highest and the second highest ATMs(per 100,000 adults) of Japan?
Your answer should be compact. 1.89. What is the difference between the highest and the second highest ATMs(per 100,000 adults) of United Kingdom?
Your answer should be compact. 2.74. What is the difference between the highest and the lowest ATMs(per 100,000 adults) in Denmark?
Your answer should be very brief. 12.38. What is the difference between the highest and the lowest ATMs(per 100,000 adults) of Honduras?
Offer a very short reply. 10.6. What is the difference between the highest and the lowest ATMs(per 100,000 adults) in Japan?
Your response must be concise. 7.32. What is the difference between the highest and the lowest ATMs(per 100,000 adults) in United Kingdom?
Ensure brevity in your answer.  7.47. 